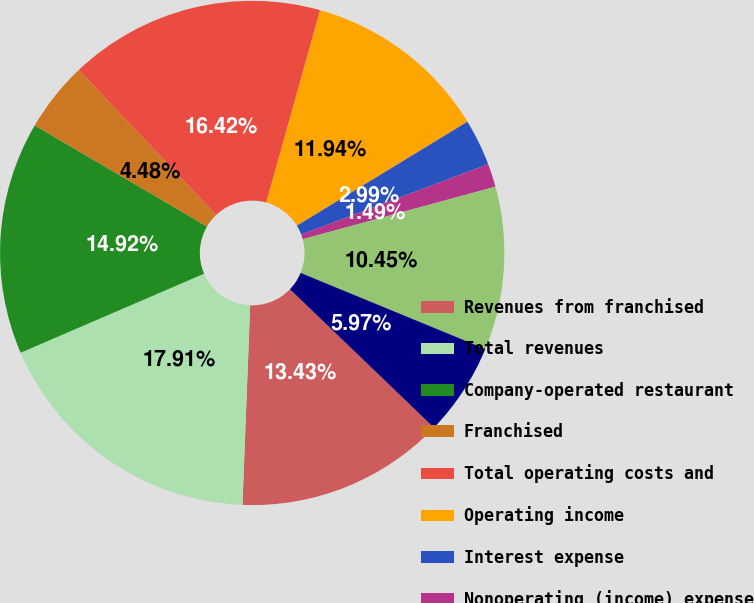<chart> <loc_0><loc_0><loc_500><loc_500><pie_chart><fcel>Revenues from franchised<fcel>Total revenues<fcel>Company-operated restaurant<fcel>Franchised<fcel>Total operating costs and<fcel>Operating income<fcel>Interest expense<fcel>Nonoperating (income) expense<fcel>Income from continuing<fcel>Provision for income taxes<nl><fcel>13.43%<fcel>17.91%<fcel>14.92%<fcel>4.48%<fcel>16.42%<fcel>11.94%<fcel>2.99%<fcel>1.49%<fcel>10.45%<fcel>5.97%<nl></chart> 